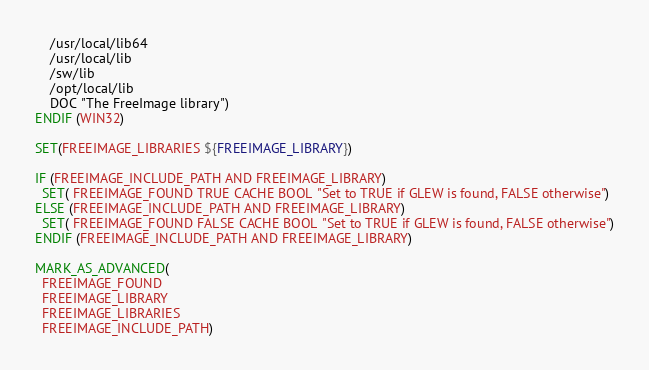<code> <loc_0><loc_0><loc_500><loc_500><_CMake_>    /usr/local/lib64
    /usr/local/lib
    /sw/lib
    /opt/local/lib
    DOC "The FreeImage library")
ENDIF (WIN32)

SET(FREEIMAGE_LIBRARIES ${FREEIMAGE_LIBRARY})

IF (FREEIMAGE_INCLUDE_PATH AND FREEIMAGE_LIBRARY)
  SET( FREEIMAGE_FOUND TRUE CACHE BOOL "Set to TRUE if GLEW is found, FALSE otherwise")
ELSE (FREEIMAGE_INCLUDE_PATH AND FREEIMAGE_LIBRARY)
  SET( FREEIMAGE_FOUND FALSE CACHE BOOL "Set to TRUE if GLEW is found, FALSE otherwise")
ENDIF (FREEIMAGE_INCLUDE_PATH AND FREEIMAGE_LIBRARY)

MARK_AS_ADVANCED(
  FREEIMAGE_FOUND
  FREEIMAGE_LIBRARY
  FREEIMAGE_LIBRARIES
  FREEIMAGE_INCLUDE_PATH)</code> 